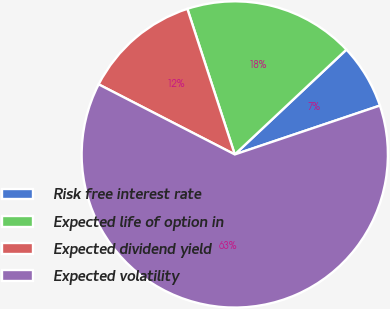Convert chart. <chart><loc_0><loc_0><loc_500><loc_500><pie_chart><fcel>Risk free interest rate<fcel>Expected life of option in<fcel>Expected dividend yield<fcel>Expected volatility<nl><fcel>6.83%<fcel>18.01%<fcel>12.42%<fcel>62.73%<nl></chart> 